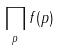<formula> <loc_0><loc_0><loc_500><loc_500>\prod _ { p } f ( p )</formula> 